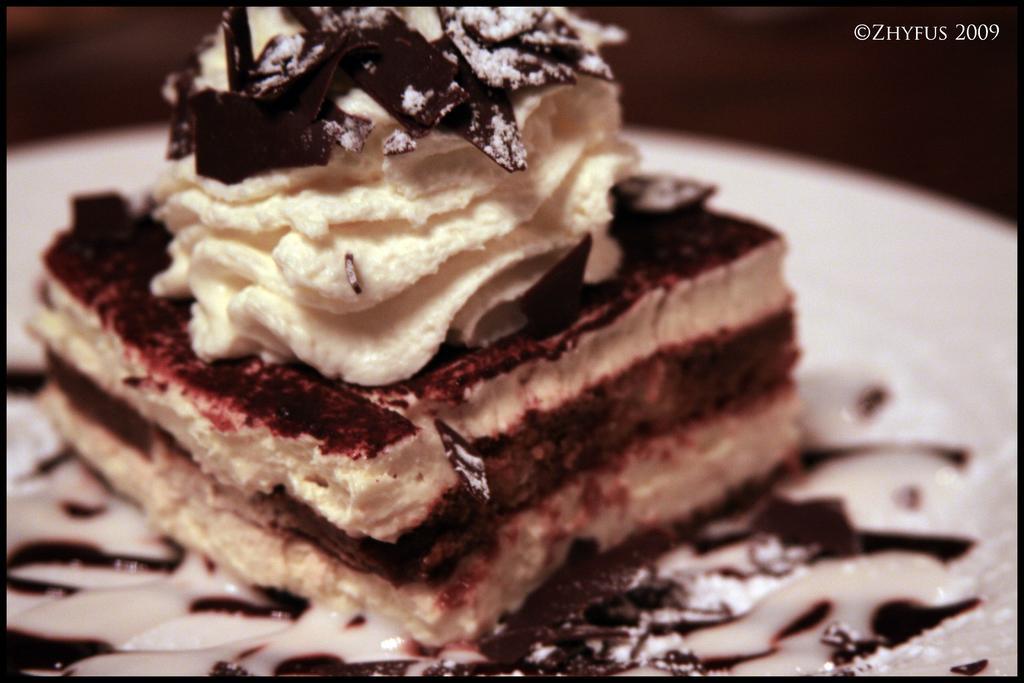Describe this image in one or two sentences. In the image on the white surface there is a piece of cake with cream on it. In the top right corner of the image there is text. 